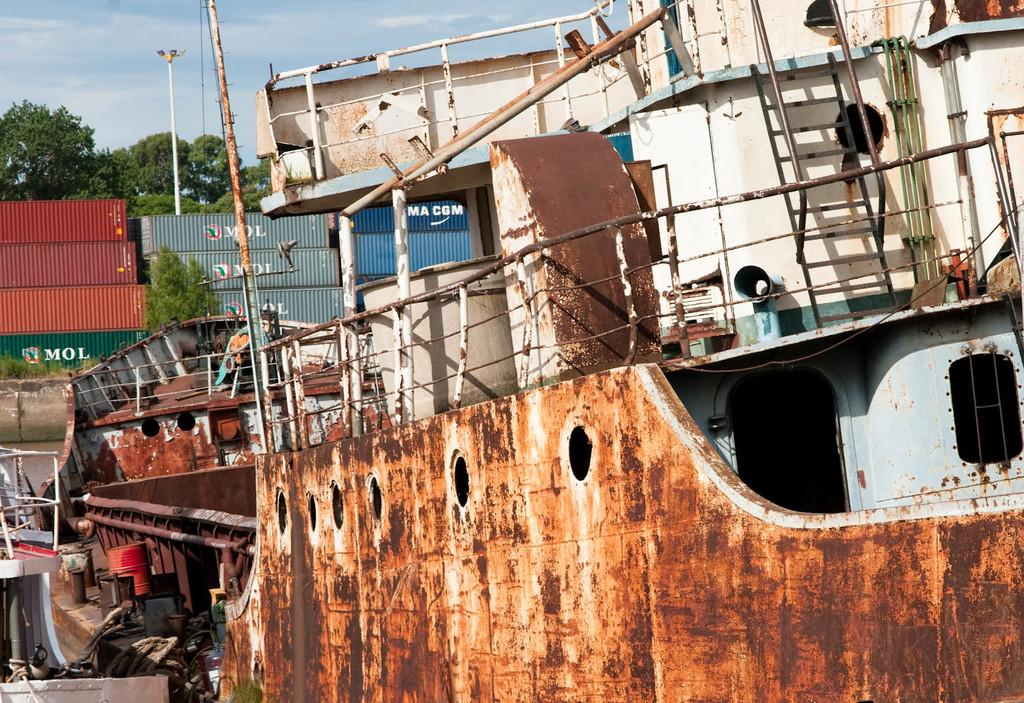<image>
Offer a succinct explanation of the picture presented. A rusty boat sits in front of MOL containers. 